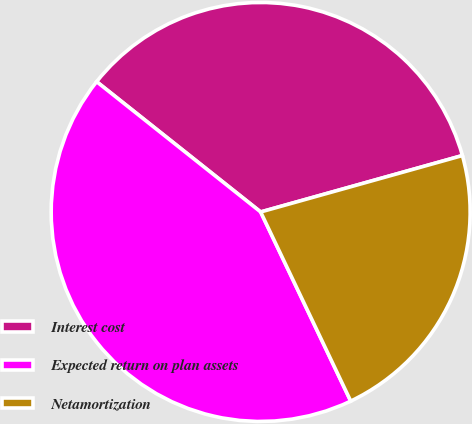Convert chart to OTSL. <chart><loc_0><loc_0><loc_500><loc_500><pie_chart><fcel>Interest cost<fcel>Expected return on plan assets<fcel>Netamortization<nl><fcel>34.98%<fcel>42.76%<fcel>22.27%<nl></chart> 